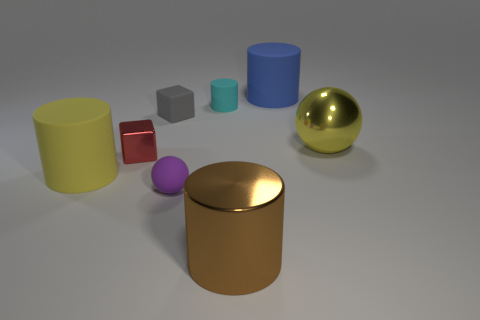What color is the cylinder that is the same size as the purple matte sphere?
Provide a short and direct response. Cyan. Are there any large matte cylinders that have the same color as the metallic sphere?
Make the answer very short. Yes. Are there fewer rubber objects in front of the purple matte sphere than brown things that are in front of the small red cube?
Give a very brief answer. Yes. What material is the small thing that is to the right of the tiny gray object and in front of the gray matte thing?
Offer a terse response. Rubber. There is a tiny gray thing; is its shape the same as the shiny object left of the brown cylinder?
Give a very brief answer. Yes. How many other objects are there of the same size as the red cube?
Offer a very short reply. 3. Is the number of big yellow shiny balls greater than the number of small brown things?
Provide a short and direct response. Yes. How many objects are both on the right side of the small matte block and behind the tiny red metallic thing?
Your answer should be very brief. 3. There is a big matte object behind the large rubber thing in front of the large yellow object that is right of the purple matte sphere; what shape is it?
Provide a succinct answer. Cylinder. What number of balls are big brown metal objects or small red things?
Provide a succinct answer. 0. 